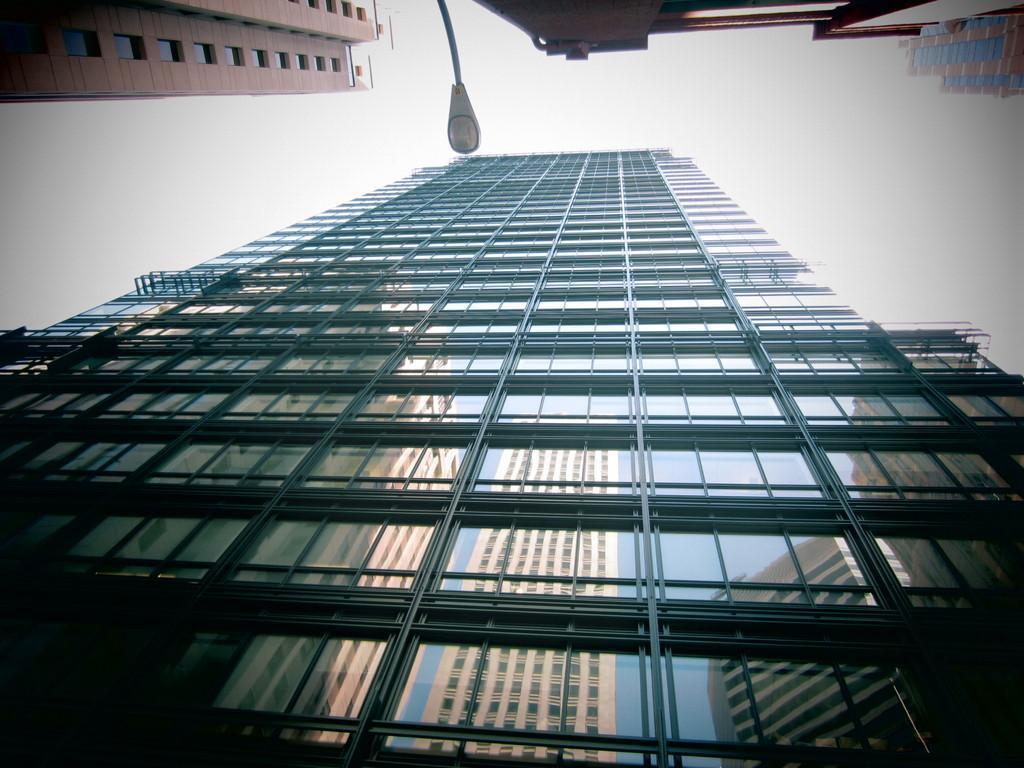Can you describe this image briefly? It's a very big building, in the middle it is a street light and this is a cloudy sky. 